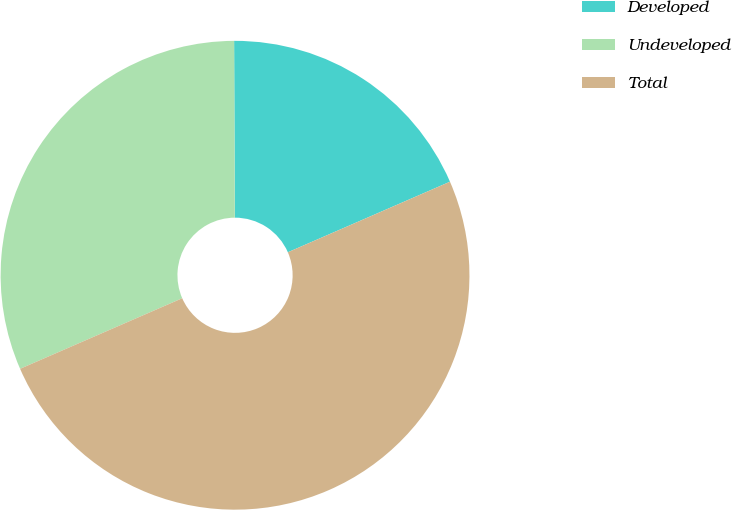Convert chart to OTSL. <chart><loc_0><loc_0><loc_500><loc_500><pie_chart><fcel>Developed<fcel>Undeveloped<fcel>Total<nl><fcel>18.53%<fcel>31.47%<fcel>50.0%<nl></chart> 